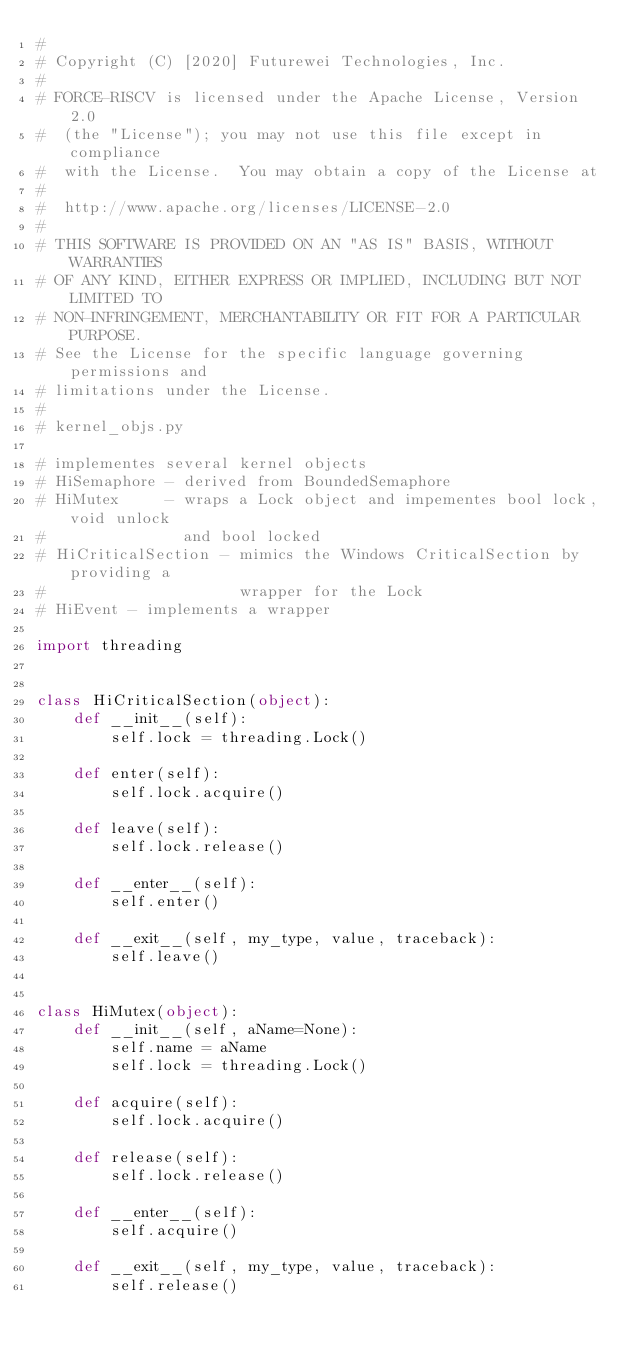Convert code to text. <code><loc_0><loc_0><loc_500><loc_500><_Python_>#
# Copyright (C) [2020] Futurewei Technologies, Inc.
#
# FORCE-RISCV is licensed under the Apache License, Version 2.0
#  (the "License"); you may not use this file except in compliance
#  with the License.  You may obtain a copy of the License at
#
#  http://www.apache.org/licenses/LICENSE-2.0
#
# THIS SOFTWARE IS PROVIDED ON AN "AS IS" BASIS, WITHOUT WARRANTIES
# OF ANY KIND, EITHER EXPRESS OR IMPLIED, INCLUDING BUT NOT LIMITED TO
# NON-INFRINGEMENT, MERCHANTABILITY OR FIT FOR A PARTICULAR PURPOSE.
# See the License for the specific language governing permissions and
# limitations under the License.
#
# kernel_objs.py

# implementes several kernel objects
# HiSemaphore - derived from BoundedSemaphore
# HiMutex     - wraps a Lock object and impementes bool lock, void unlock
#               and bool locked
# HiCriticalSection - mimics the Windows CriticalSection by providing a
#                     wrapper for the Lock
# HiEvent - implements a wrapper

import threading


class HiCriticalSection(object):
    def __init__(self):
        self.lock = threading.Lock()

    def enter(self):
        self.lock.acquire()

    def leave(self):
        self.lock.release()

    def __enter__(self):
        self.enter()

    def __exit__(self, my_type, value, traceback):
        self.leave()


class HiMutex(object):
    def __init__(self, aName=None):
        self.name = aName
        self.lock = threading.Lock()

    def acquire(self):
        self.lock.acquire()

    def release(self):
        self.lock.release()

    def __enter__(self):
        self.acquire()

    def __exit__(self, my_type, value, traceback):
        self.release()
</code> 